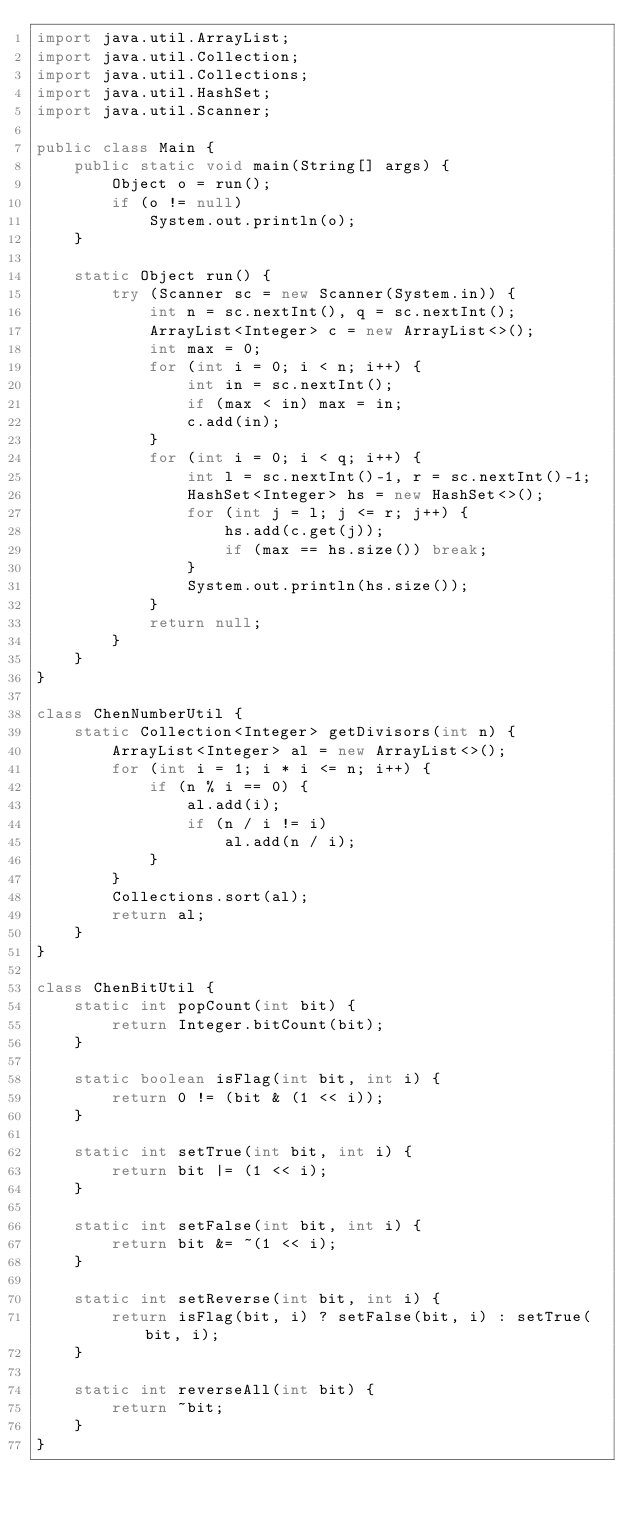Convert code to text. <code><loc_0><loc_0><loc_500><loc_500><_Java_>import java.util.ArrayList;
import java.util.Collection;
import java.util.Collections;
import java.util.HashSet;
import java.util.Scanner;

public class Main {
    public static void main(String[] args) {
        Object o = run();
        if (o != null)
            System.out.println(o);
    }

    static Object run() {
        try (Scanner sc = new Scanner(System.in)) {
            int n = sc.nextInt(), q = sc.nextInt();
            ArrayList<Integer> c = new ArrayList<>();
            int max = 0;
            for (int i = 0; i < n; i++) {
                int in = sc.nextInt();
                if (max < in) max = in;
                c.add(in);
            }
            for (int i = 0; i < q; i++) {
                int l = sc.nextInt()-1, r = sc.nextInt()-1;
                HashSet<Integer> hs = new HashSet<>();
                for (int j = l; j <= r; j++) {
                    hs.add(c.get(j));
                    if (max == hs.size()) break;
                }
                System.out.println(hs.size());
            }
            return null;
        }
    }
}

class ChenNumberUtil {
    static Collection<Integer> getDivisors(int n) {
        ArrayList<Integer> al = new ArrayList<>();
        for (int i = 1; i * i <= n; i++) {
            if (n % i == 0) {
                al.add(i);
                if (n / i != i)
                    al.add(n / i);
            }
        }
        Collections.sort(al);
        return al;
    }
}

class ChenBitUtil {
    static int popCount(int bit) {
        return Integer.bitCount(bit);
    }

    static boolean isFlag(int bit, int i) {
        return 0 != (bit & (1 << i));
    }

    static int setTrue(int bit, int i) {
        return bit |= (1 << i);
    }

    static int setFalse(int bit, int i) {
        return bit &= ~(1 << i);
    }

    static int setReverse(int bit, int i) {
        return isFlag(bit, i) ? setFalse(bit, i) : setTrue(bit, i);
    }

    static int reverseAll(int bit) {
        return ~bit;
    }
}
</code> 